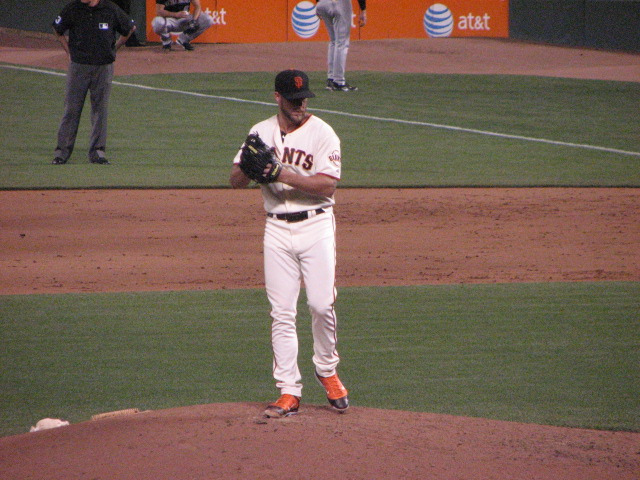Read and extract the text from this image. NTS t at&t 